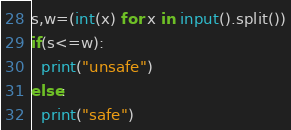Convert code to text. <code><loc_0><loc_0><loc_500><loc_500><_Python_>s,w=(int(x) for x in input().split())
if(s<=w):
  print("unsafe")
else:
  print("safe")</code> 